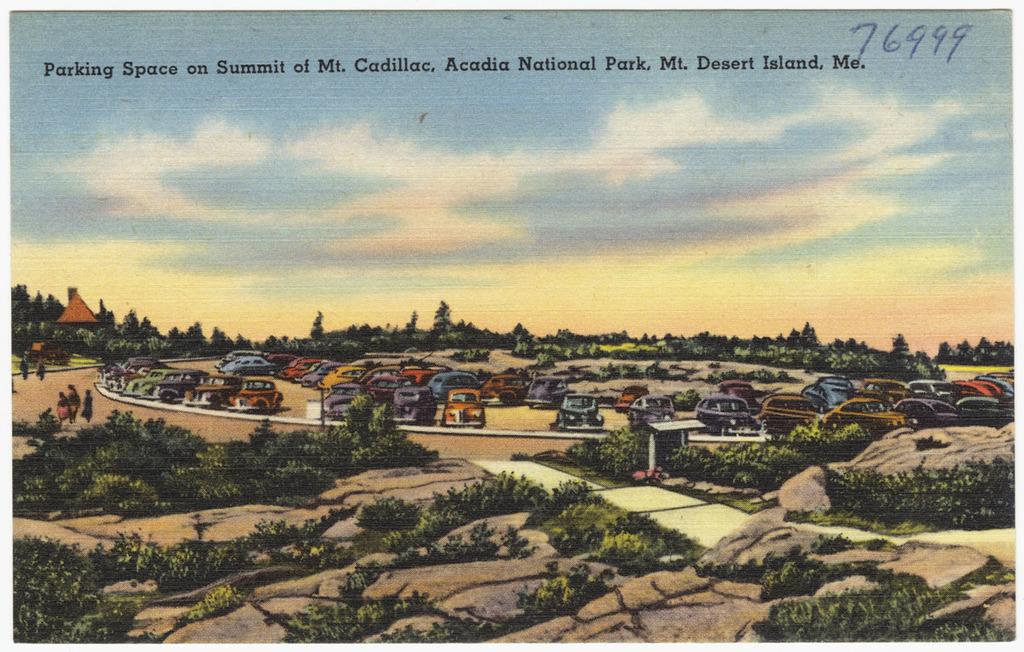What island is this?
Ensure brevity in your answer.  Mt. desert island. What is the number that is hand written?
Offer a terse response. 76999. 